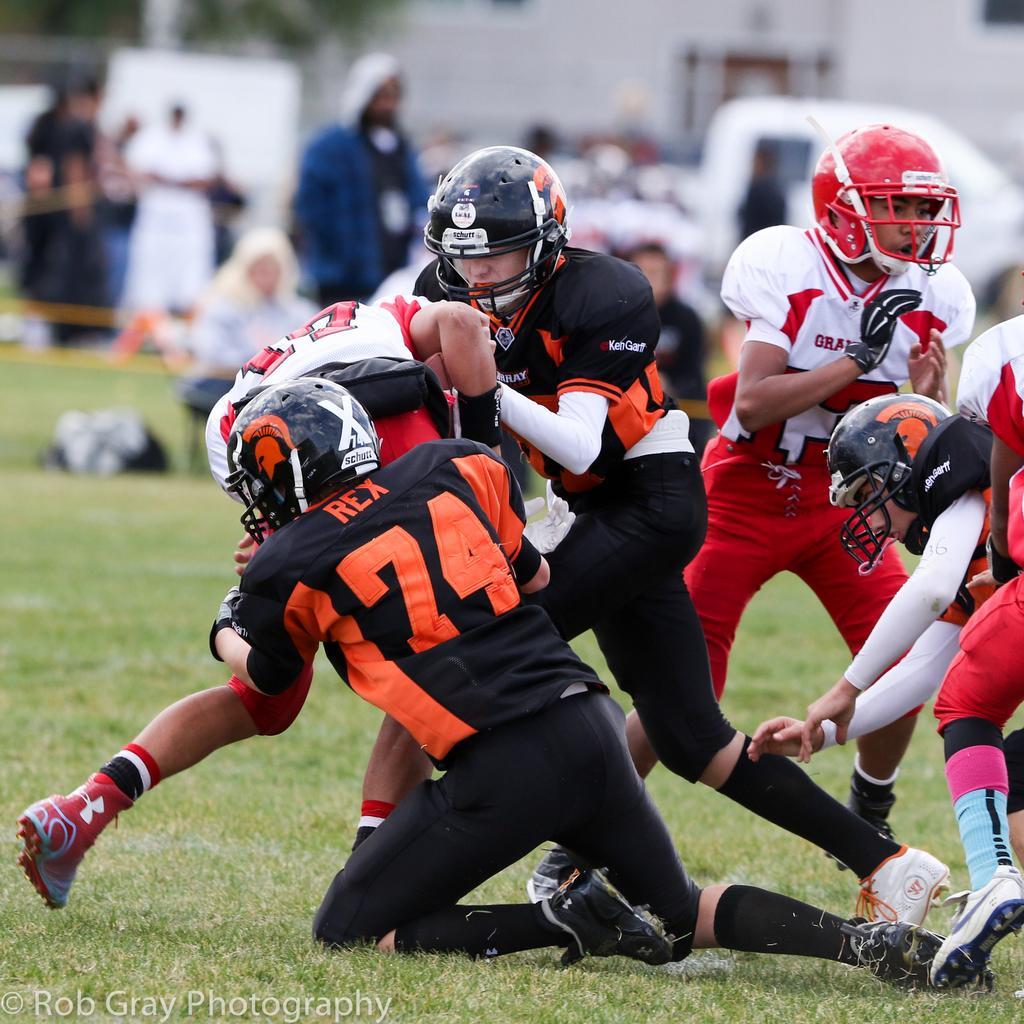Please provide a concise description of this image. In this picture I can see few players on the ground and they are wearing helmets on their heads and I can see few people are standing in the back and few are sitting and I can see building and a tree in the back. 